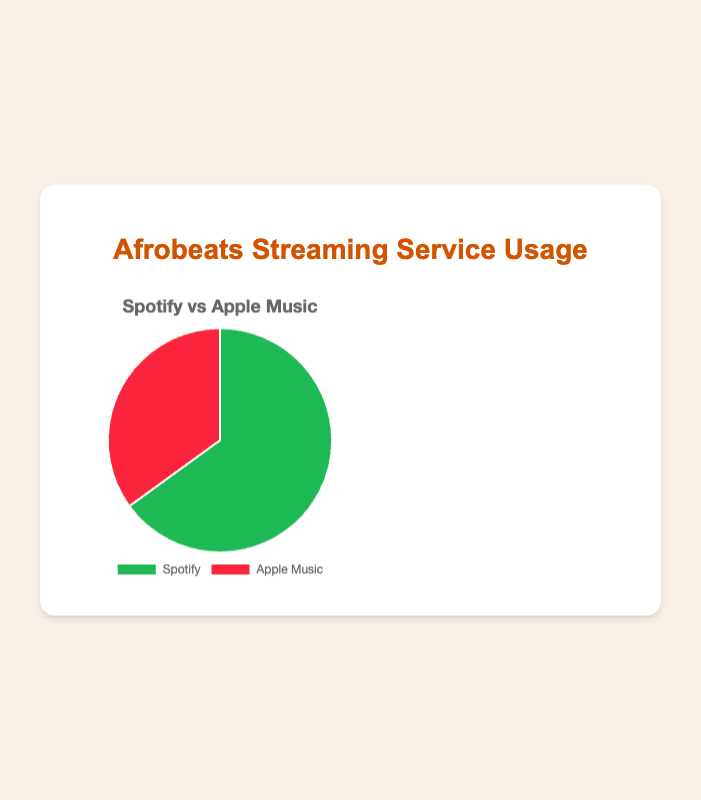what percentage of streaming service usage does Spotify have? According to the pie chart, Spotify accounts for 65% of the streaming services usage.
Answer: 65% What percentage of streaming service usage does Apple Music have? The pie chart shows that Apple Music accounts for 35% of the streaming services usage.
Answer: 35% How much more popular is Spotify compared to Apple Music in terms of streaming service usage? To find how much more popular Spotify is, you subtract Apple Music's usage percentage from Spotify's usage percentage: 65% - 35% = 30%.
Answer: 30% What is the combined percentage of streaming service usage for both Spotify and Apple Music? The combined percentage for both streaming services would be the sum of their individual percentages: 65% + 35% = 100%.
Answer: 100% By how many percentage points does Spotify lead over Apple Music? Spotify leads Apple Music by the difference in their percentages: 65% - 35% = 30 percentage points.
Answer: 30 Which streaming service has the higher usage for Afrobeats music? The pie chart indicates that Spotify has higher usage than Apple Music for Afrobeats music with 65%.
Answer: Spotify What are the colors representing Spotify and Apple Music in the pie chart? In the pie chart, Spotify is represented by green and Apple Music is represented by red.
Answer: Green for Spotify, Red for Apple Music If the total streaming hours for Afrobeats music is 1000 hours, how many hours are streamed on Spotify and Apple Music? For Spotify: 65% of 1000 = 650 hours. For Apple Music: 35% of 1000 = 350 hours.
Answer: Spotify: 650 hours, Apple Music: 350 hours If Apple Music's usage increased by 10 percentage points, what would the new usage percentages be for Spotify and Apple Music? If Apple Music's usage increased by 10, it would be 35% + 10% = 45%. Since total must be 100%, Spotify's would decrease by 10 points: 65% - 10% = 55%. New percentages: Spotify = 55%, Apple Music = 45%.
Answer: Spotify: 55%, Apple Music: 45% 